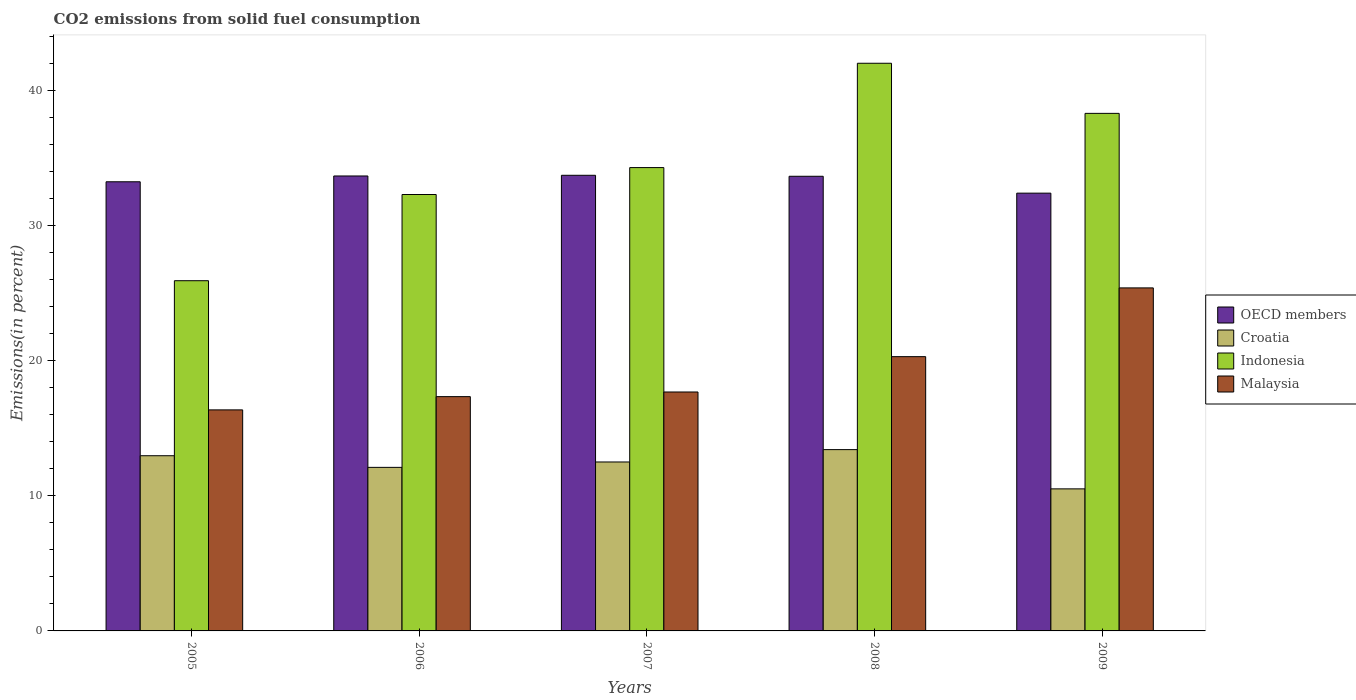How many different coloured bars are there?
Offer a very short reply. 4. Are the number of bars per tick equal to the number of legend labels?
Give a very brief answer. Yes. Are the number of bars on each tick of the X-axis equal?
Your answer should be very brief. Yes. How many bars are there on the 2nd tick from the left?
Provide a succinct answer. 4. How many bars are there on the 1st tick from the right?
Offer a terse response. 4. What is the label of the 4th group of bars from the left?
Provide a succinct answer. 2008. What is the total CO2 emitted in Croatia in 2005?
Make the answer very short. 12.97. Across all years, what is the maximum total CO2 emitted in Malaysia?
Make the answer very short. 25.39. Across all years, what is the minimum total CO2 emitted in OECD members?
Offer a very short reply. 32.4. In which year was the total CO2 emitted in Croatia maximum?
Give a very brief answer. 2008. In which year was the total CO2 emitted in Croatia minimum?
Your answer should be very brief. 2009. What is the total total CO2 emitted in Indonesia in the graph?
Provide a short and direct response. 172.83. What is the difference between the total CO2 emitted in Croatia in 2007 and that in 2008?
Your answer should be very brief. -0.91. What is the difference between the total CO2 emitted in Croatia in 2008 and the total CO2 emitted in Malaysia in 2006?
Your answer should be compact. -3.92. What is the average total CO2 emitted in OECD members per year?
Keep it short and to the point. 33.34. In the year 2005, what is the difference between the total CO2 emitted in Malaysia and total CO2 emitted in Croatia?
Offer a terse response. 3.39. What is the ratio of the total CO2 emitted in Croatia in 2005 to that in 2006?
Provide a short and direct response. 1.07. What is the difference between the highest and the second highest total CO2 emitted in Croatia?
Give a very brief answer. 0.45. What is the difference between the highest and the lowest total CO2 emitted in Indonesia?
Offer a terse response. 16.09. What does the 3rd bar from the left in 2005 represents?
Make the answer very short. Indonesia. What does the 3rd bar from the right in 2008 represents?
Your answer should be very brief. Croatia. Is it the case that in every year, the sum of the total CO2 emitted in Malaysia and total CO2 emitted in Indonesia is greater than the total CO2 emitted in Croatia?
Ensure brevity in your answer.  Yes. How many bars are there?
Offer a terse response. 20. What is the difference between two consecutive major ticks on the Y-axis?
Keep it short and to the point. 10. Does the graph contain any zero values?
Your answer should be very brief. No. Does the graph contain grids?
Ensure brevity in your answer.  No. Where does the legend appear in the graph?
Make the answer very short. Center right. How are the legend labels stacked?
Keep it short and to the point. Vertical. What is the title of the graph?
Your answer should be compact. CO2 emissions from solid fuel consumption. What is the label or title of the Y-axis?
Provide a short and direct response. Emissions(in percent). What is the Emissions(in percent) in OECD members in 2005?
Provide a succinct answer. 33.24. What is the Emissions(in percent) in Croatia in 2005?
Provide a succinct answer. 12.97. What is the Emissions(in percent) of Indonesia in 2005?
Ensure brevity in your answer.  25.92. What is the Emissions(in percent) in Malaysia in 2005?
Provide a succinct answer. 16.36. What is the Emissions(in percent) of OECD members in 2006?
Make the answer very short. 33.67. What is the Emissions(in percent) in Croatia in 2006?
Offer a very short reply. 12.1. What is the Emissions(in percent) in Indonesia in 2006?
Make the answer very short. 32.3. What is the Emissions(in percent) in Malaysia in 2006?
Ensure brevity in your answer.  17.34. What is the Emissions(in percent) in OECD members in 2007?
Provide a succinct answer. 33.72. What is the Emissions(in percent) in Croatia in 2007?
Offer a very short reply. 12.5. What is the Emissions(in percent) in Indonesia in 2007?
Provide a short and direct response. 34.29. What is the Emissions(in percent) of Malaysia in 2007?
Give a very brief answer. 17.68. What is the Emissions(in percent) in OECD members in 2008?
Keep it short and to the point. 33.65. What is the Emissions(in percent) in Croatia in 2008?
Offer a terse response. 13.42. What is the Emissions(in percent) in Indonesia in 2008?
Ensure brevity in your answer.  42.01. What is the Emissions(in percent) in Malaysia in 2008?
Give a very brief answer. 20.3. What is the Emissions(in percent) of OECD members in 2009?
Offer a very short reply. 32.4. What is the Emissions(in percent) in Croatia in 2009?
Offer a very short reply. 10.51. What is the Emissions(in percent) of Indonesia in 2009?
Offer a very short reply. 38.3. What is the Emissions(in percent) of Malaysia in 2009?
Offer a very short reply. 25.39. Across all years, what is the maximum Emissions(in percent) of OECD members?
Provide a short and direct response. 33.72. Across all years, what is the maximum Emissions(in percent) of Croatia?
Your answer should be compact. 13.42. Across all years, what is the maximum Emissions(in percent) of Indonesia?
Offer a terse response. 42.01. Across all years, what is the maximum Emissions(in percent) of Malaysia?
Ensure brevity in your answer.  25.39. Across all years, what is the minimum Emissions(in percent) of OECD members?
Your answer should be very brief. 32.4. Across all years, what is the minimum Emissions(in percent) of Croatia?
Provide a succinct answer. 10.51. Across all years, what is the minimum Emissions(in percent) in Indonesia?
Provide a succinct answer. 25.92. Across all years, what is the minimum Emissions(in percent) in Malaysia?
Make the answer very short. 16.36. What is the total Emissions(in percent) of OECD members in the graph?
Provide a succinct answer. 166.68. What is the total Emissions(in percent) of Croatia in the graph?
Make the answer very short. 61.51. What is the total Emissions(in percent) in Indonesia in the graph?
Your answer should be very brief. 172.83. What is the total Emissions(in percent) of Malaysia in the graph?
Make the answer very short. 97.07. What is the difference between the Emissions(in percent) in OECD members in 2005 and that in 2006?
Your answer should be compact. -0.43. What is the difference between the Emissions(in percent) of Croatia in 2005 and that in 2006?
Ensure brevity in your answer.  0.86. What is the difference between the Emissions(in percent) in Indonesia in 2005 and that in 2006?
Ensure brevity in your answer.  -6.38. What is the difference between the Emissions(in percent) in Malaysia in 2005 and that in 2006?
Your answer should be compact. -0.98. What is the difference between the Emissions(in percent) in OECD members in 2005 and that in 2007?
Keep it short and to the point. -0.48. What is the difference between the Emissions(in percent) in Croatia in 2005 and that in 2007?
Offer a very short reply. 0.46. What is the difference between the Emissions(in percent) in Indonesia in 2005 and that in 2007?
Keep it short and to the point. -8.37. What is the difference between the Emissions(in percent) of Malaysia in 2005 and that in 2007?
Provide a succinct answer. -1.32. What is the difference between the Emissions(in percent) of OECD members in 2005 and that in 2008?
Your response must be concise. -0.41. What is the difference between the Emissions(in percent) of Croatia in 2005 and that in 2008?
Ensure brevity in your answer.  -0.45. What is the difference between the Emissions(in percent) in Indonesia in 2005 and that in 2008?
Your answer should be compact. -16.09. What is the difference between the Emissions(in percent) of Malaysia in 2005 and that in 2008?
Keep it short and to the point. -3.94. What is the difference between the Emissions(in percent) of OECD members in 2005 and that in 2009?
Keep it short and to the point. 0.84. What is the difference between the Emissions(in percent) in Croatia in 2005 and that in 2009?
Offer a very short reply. 2.45. What is the difference between the Emissions(in percent) of Indonesia in 2005 and that in 2009?
Provide a succinct answer. -12.38. What is the difference between the Emissions(in percent) in Malaysia in 2005 and that in 2009?
Ensure brevity in your answer.  -9.03. What is the difference between the Emissions(in percent) of OECD members in 2006 and that in 2007?
Your answer should be very brief. -0.05. What is the difference between the Emissions(in percent) of Croatia in 2006 and that in 2007?
Ensure brevity in your answer.  -0.4. What is the difference between the Emissions(in percent) in Indonesia in 2006 and that in 2007?
Your response must be concise. -1.99. What is the difference between the Emissions(in percent) of Malaysia in 2006 and that in 2007?
Make the answer very short. -0.34. What is the difference between the Emissions(in percent) of OECD members in 2006 and that in 2008?
Your response must be concise. 0.02. What is the difference between the Emissions(in percent) of Croatia in 2006 and that in 2008?
Ensure brevity in your answer.  -1.31. What is the difference between the Emissions(in percent) of Indonesia in 2006 and that in 2008?
Provide a succinct answer. -9.71. What is the difference between the Emissions(in percent) of Malaysia in 2006 and that in 2008?
Your answer should be very brief. -2.96. What is the difference between the Emissions(in percent) of OECD members in 2006 and that in 2009?
Your answer should be very brief. 1.27. What is the difference between the Emissions(in percent) in Croatia in 2006 and that in 2009?
Give a very brief answer. 1.59. What is the difference between the Emissions(in percent) of Indonesia in 2006 and that in 2009?
Give a very brief answer. -6.01. What is the difference between the Emissions(in percent) of Malaysia in 2006 and that in 2009?
Give a very brief answer. -8.05. What is the difference between the Emissions(in percent) in OECD members in 2007 and that in 2008?
Provide a succinct answer. 0.07. What is the difference between the Emissions(in percent) of Croatia in 2007 and that in 2008?
Make the answer very short. -0.91. What is the difference between the Emissions(in percent) in Indonesia in 2007 and that in 2008?
Offer a very short reply. -7.72. What is the difference between the Emissions(in percent) in Malaysia in 2007 and that in 2008?
Keep it short and to the point. -2.62. What is the difference between the Emissions(in percent) in OECD members in 2007 and that in 2009?
Provide a succinct answer. 1.32. What is the difference between the Emissions(in percent) in Croatia in 2007 and that in 2009?
Offer a terse response. 1.99. What is the difference between the Emissions(in percent) in Indonesia in 2007 and that in 2009?
Ensure brevity in your answer.  -4.01. What is the difference between the Emissions(in percent) in Malaysia in 2007 and that in 2009?
Your answer should be very brief. -7.7. What is the difference between the Emissions(in percent) of OECD members in 2008 and that in 2009?
Your response must be concise. 1.25. What is the difference between the Emissions(in percent) of Croatia in 2008 and that in 2009?
Provide a succinct answer. 2.9. What is the difference between the Emissions(in percent) in Indonesia in 2008 and that in 2009?
Make the answer very short. 3.71. What is the difference between the Emissions(in percent) of Malaysia in 2008 and that in 2009?
Offer a very short reply. -5.09. What is the difference between the Emissions(in percent) in OECD members in 2005 and the Emissions(in percent) in Croatia in 2006?
Give a very brief answer. 21.14. What is the difference between the Emissions(in percent) in OECD members in 2005 and the Emissions(in percent) in Indonesia in 2006?
Ensure brevity in your answer.  0.94. What is the difference between the Emissions(in percent) of OECD members in 2005 and the Emissions(in percent) of Malaysia in 2006?
Offer a terse response. 15.9. What is the difference between the Emissions(in percent) in Croatia in 2005 and the Emissions(in percent) in Indonesia in 2006?
Give a very brief answer. -19.33. What is the difference between the Emissions(in percent) of Croatia in 2005 and the Emissions(in percent) of Malaysia in 2006?
Your answer should be very brief. -4.37. What is the difference between the Emissions(in percent) in Indonesia in 2005 and the Emissions(in percent) in Malaysia in 2006?
Your answer should be compact. 8.58. What is the difference between the Emissions(in percent) in OECD members in 2005 and the Emissions(in percent) in Croatia in 2007?
Keep it short and to the point. 20.74. What is the difference between the Emissions(in percent) of OECD members in 2005 and the Emissions(in percent) of Indonesia in 2007?
Your response must be concise. -1.05. What is the difference between the Emissions(in percent) in OECD members in 2005 and the Emissions(in percent) in Malaysia in 2007?
Ensure brevity in your answer.  15.56. What is the difference between the Emissions(in percent) in Croatia in 2005 and the Emissions(in percent) in Indonesia in 2007?
Keep it short and to the point. -21.33. What is the difference between the Emissions(in percent) in Croatia in 2005 and the Emissions(in percent) in Malaysia in 2007?
Offer a terse response. -4.72. What is the difference between the Emissions(in percent) of Indonesia in 2005 and the Emissions(in percent) of Malaysia in 2007?
Offer a terse response. 8.24. What is the difference between the Emissions(in percent) of OECD members in 2005 and the Emissions(in percent) of Croatia in 2008?
Provide a succinct answer. 19.82. What is the difference between the Emissions(in percent) in OECD members in 2005 and the Emissions(in percent) in Indonesia in 2008?
Your answer should be very brief. -8.77. What is the difference between the Emissions(in percent) in OECD members in 2005 and the Emissions(in percent) in Malaysia in 2008?
Offer a terse response. 12.94. What is the difference between the Emissions(in percent) of Croatia in 2005 and the Emissions(in percent) of Indonesia in 2008?
Your response must be concise. -29.05. What is the difference between the Emissions(in percent) of Croatia in 2005 and the Emissions(in percent) of Malaysia in 2008?
Your answer should be compact. -7.33. What is the difference between the Emissions(in percent) in Indonesia in 2005 and the Emissions(in percent) in Malaysia in 2008?
Offer a very short reply. 5.62. What is the difference between the Emissions(in percent) in OECD members in 2005 and the Emissions(in percent) in Croatia in 2009?
Provide a succinct answer. 22.73. What is the difference between the Emissions(in percent) in OECD members in 2005 and the Emissions(in percent) in Indonesia in 2009?
Give a very brief answer. -5.06. What is the difference between the Emissions(in percent) in OECD members in 2005 and the Emissions(in percent) in Malaysia in 2009?
Keep it short and to the point. 7.85. What is the difference between the Emissions(in percent) of Croatia in 2005 and the Emissions(in percent) of Indonesia in 2009?
Give a very brief answer. -25.34. What is the difference between the Emissions(in percent) in Croatia in 2005 and the Emissions(in percent) in Malaysia in 2009?
Make the answer very short. -12.42. What is the difference between the Emissions(in percent) in Indonesia in 2005 and the Emissions(in percent) in Malaysia in 2009?
Give a very brief answer. 0.53. What is the difference between the Emissions(in percent) in OECD members in 2006 and the Emissions(in percent) in Croatia in 2007?
Your answer should be compact. 21.17. What is the difference between the Emissions(in percent) of OECD members in 2006 and the Emissions(in percent) of Indonesia in 2007?
Make the answer very short. -0.62. What is the difference between the Emissions(in percent) in OECD members in 2006 and the Emissions(in percent) in Malaysia in 2007?
Your answer should be very brief. 15.99. What is the difference between the Emissions(in percent) in Croatia in 2006 and the Emissions(in percent) in Indonesia in 2007?
Give a very brief answer. -22.19. What is the difference between the Emissions(in percent) of Croatia in 2006 and the Emissions(in percent) of Malaysia in 2007?
Provide a short and direct response. -5.58. What is the difference between the Emissions(in percent) of Indonesia in 2006 and the Emissions(in percent) of Malaysia in 2007?
Your response must be concise. 14.62. What is the difference between the Emissions(in percent) in OECD members in 2006 and the Emissions(in percent) in Croatia in 2008?
Keep it short and to the point. 20.25. What is the difference between the Emissions(in percent) in OECD members in 2006 and the Emissions(in percent) in Indonesia in 2008?
Make the answer very short. -8.34. What is the difference between the Emissions(in percent) of OECD members in 2006 and the Emissions(in percent) of Malaysia in 2008?
Offer a terse response. 13.37. What is the difference between the Emissions(in percent) of Croatia in 2006 and the Emissions(in percent) of Indonesia in 2008?
Your answer should be very brief. -29.91. What is the difference between the Emissions(in percent) of Croatia in 2006 and the Emissions(in percent) of Malaysia in 2008?
Give a very brief answer. -8.19. What is the difference between the Emissions(in percent) in Indonesia in 2006 and the Emissions(in percent) in Malaysia in 2008?
Provide a short and direct response. 12. What is the difference between the Emissions(in percent) of OECD members in 2006 and the Emissions(in percent) of Croatia in 2009?
Your response must be concise. 23.16. What is the difference between the Emissions(in percent) in OECD members in 2006 and the Emissions(in percent) in Indonesia in 2009?
Your answer should be very brief. -4.63. What is the difference between the Emissions(in percent) of OECD members in 2006 and the Emissions(in percent) of Malaysia in 2009?
Your response must be concise. 8.28. What is the difference between the Emissions(in percent) of Croatia in 2006 and the Emissions(in percent) of Indonesia in 2009?
Offer a terse response. -26.2. What is the difference between the Emissions(in percent) in Croatia in 2006 and the Emissions(in percent) in Malaysia in 2009?
Provide a succinct answer. -13.28. What is the difference between the Emissions(in percent) of Indonesia in 2006 and the Emissions(in percent) of Malaysia in 2009?
Give a very brief answer. 6.91. What is the difference between the Emissions(in percent) of OECD members in 2007 and the Emissions(in percent) of Croatia in 2008?
Provide a short and direct response. 20.3. What is the difference between the Emissions(in percent) of OECD members in 2007 and the Emissions(in percent) of Indonesia in 2008?
Keep it short and to the point. -8.29. What is the difference between the Emissions(in percent) of OECD members in 2007 and the Emissions(in percent) of Malaysia in 2008?
Your answer should be compact. 13.42. What is the difference between the Emissions(in percent) of Croatia in 2007 and the Emissions(in percent) of Indonesia in 2008?
Your answer should be very brief. -29.51. What is the difference between the Emissions(in percent) in Croatia in 2007 and the Emissions(in percent) in Malaysia in 2008?
Offer a very short reply. -7.79. What is the difference between the Emissions(in percent) of Indonesia in 2007 and the Emissions(in percent) of Malaysia in 2008?
Make the answer very short. 13.99. What is the difference between the Emissions(in percent) in OECD members in 2007 and the Emissions(in percent) in Croatia in 2009?
Make the answer very short. 23.21. What is the difference between the Emissions(in percent) of OECD members in 2007 and the Emissions(in percent) of Indonesia in 2009?
Keep it short and to the point. -4.58. What is the difference between the Emissions(in percent) in OECD members in 2007 and the Emissions(in percent) in Malaysia in 2009?
Your answer should be very brief. 8.33. What is the difference between the Emissions(in percent) of Croatia in 2007 and the Emissions(in percent) of Indonesia in 2009?
Your answer should be very brief. -25.8. What is the difference between the Emissions(in percent) in Croatia in 2007 and the Emissions(in percent) in Malaysia in 2009?
Offer a terse response. -12.88. What is the difference between the Emissions(in percent) in Indonesia in 2007 and the Emissions(in percent) in Malaysia in 2009?
Give a very brief answer. 8.9. What is the difference between the Emissions(in percent) of OECD members in 2008 and the Emissions(in percent) of Croatia in 2009?
Your answer should be compact. 23.13. What is the difference between the Emissions(in percent) of OECD members in 2008 and the Emissions(in percent) of Indonesia in 2009?
Your answer should be very brief. -4.66. What is the difference between the Emissions(in percent) of OECD members in 2008 and the Emissions(in percent) of Malaysia in 2009?
Offer a terse response. 8.26. What is the difference between the Emissions(in percent) of Croatia in 2008 and the Emissions(in percent) of Indonesia in 2009?
Your answer should be compact. -24.89. What is the difference between the Emissions(in percent) of Croatia in 2008 and the Emissions(in percent) of Malaysia in 2009?
Offer a very short reply. -11.97. What is the difference between the Emissions(in percent) of Indonesia in 2008 and the Emissions(in percent) of Malaysia in 2009?
Give a very brief answer. 16.63. What is the average Emissions(in percent) in OECD members per year?
Give a very brief answer. 33.34. What is the average Emissions(in percent) in Croatia per year?
Provide a succinct answer. 12.3. What is the average Emissions(in percent) of Indonesia per year?
Offer a very short reply. 34.57. What is the average Emissions(in percent) in Malaysia per year?
Your response must be concise. 19.41. In the year 2005, what is the difference between the Emissions(in percent) in OECD members and Emissions(in percent) in Croatia?
Offer a terse response. 20.27. In the year 2005, what is the difference between the Emissions(in percent) in OECD members and Emissions(in percent) in Indonesia?
Offer a terse response. 7.32. In the year 2005, what is the difference between the Emissions(in percent) of OECD members and Emissions(in percent) of Malaysia?
Your response must be concise. 16.88. In the year 2005, what is the difference between the Emissions(in percent) of Croatia and Emissions(in percent) of Indonesia?
Offer a terse response. -12.95. In the year 2005, what is the difference between the Emissions(in percent) in Croatia and Emissions(in percent) in Malaysia?
Your answer should be compact. -3.39. In the year 2005, what is the difference between the Emissions(in percent) in Indonesia and Emissions(in percent) in Malaysia?
Offer a very short reply. 9.56. In the year 2006, what is the difference between the Emissions(in percent) in OECD members and Emissions(in percent) in Croatia?
Provide a short and direct response. 21.57. In the year 2006, what is the difference between the Emissions(in percent) of OECD members and Emissions(in percent) of Indonesia?
Make the answer very short. 1.37. In the year 2006, what is the difference between the Emissions(in percent) in OECD members and Emissions(in percent) in Malaysia?
Ensure brevity in your answer.  16.33. In the year 2006, what is the difference between the Emissions(in percent) in Croatia and Emissions(in percent) in Indonesia?
Your answer should be compact. -20.19. In the year 2006, what is the difference between the Emissions(in percent) of Croatia and Emissions(in percent) of Malaysia?
Keep it short and to the point. -5.23. In the year 2006, what is the difference between the Emissions(in percent) of Indonesia and Emissions(in percent) of Malaysia?
Your answer should be compact. 14.96. In the year 2007, what is the difference between the Emissions(in percent) of OECD members and Emissions(in percent) of Croatia?
Provide a short and direct response. 21.22. In the year 2007, what is the difference between the Emissions(in percent) in OECD members and Emissions(in percent) in Indonesia?
Make the answer very short. -0.57. In the year 2007, what is the difference between the Emissions(in percent) in OECD members and Emissions(in percent) in Malaysia?
Ensure brevity in your answer.  16.04. In the year 2007, what is the difference between the Emissions(in percent) in Croatia and Emissions(in percent) in Indonesia?
Your answer should be very brief. -21.79. In the year 2007, what is the difference between the Emissions(in percent) of Croatia and Emissions(in percent) of Malaysia?
Ensure brevity in your answer.  -5.18. In the year 2007, what is the difference between the Emissions(in percent) of Indonesia and Emissions(in percent) of Malaysia?
Provide a short and direct response. 16.61. In the year 2008, what is the difference between the Emissions(in percent) of OECD members and Emissions(in percent) of Croatia?
Provide a succinct answer. 20.23. In the year 2008, what is the difference between the Emissions(in percent) in OECD members and Emissions(in percent) in Indonesia?
Offer a terse response. -8.36. In the year 2008, what is the difference between the Emissions(in percent) of OECD members and Emissions(in percent) of Malaysia?
Make the answer very short. 13.35. In the year 2008, what is the difference between the Emissions(in percent) of Croatia and Emissions(in percent) of Indonesia?
Provide a short and direct response. -28.59. In the year 2008, what is the difference between the Emissions(in percent) in Croatia and Emissions(in percent) in Malaysia?
Ensure brevity in your answer.  -6.88. In the year 2008, what is the difference between the Emissions(in percent) of Indonesia and Emissions(in percent) of Malaysia?
Your response must be concise. 21.71. In the year 2009, what is the difference between the Emissions(in percent) in OECD members and Emissions(in percent) in Croatia?
Your response must be concise. 21.89. In the year 2009, what is the difference between the Emissions(in percent) in OECD members and Emissions(in percent) in Indonesia?
Make the answer very short. -5.9. In the year 2009, what is the difference between the Emissions(in percent) in OECD members and Emissions(in percent) in Malaysia?
Provide a short and direct response. 7.01. In the year 2009, what is the difference between the Emissions(in percent) of Croatia and Emissions(in percent) of Indonesia?
Offer a terse response. -27.79. In the year 2009, what is the difference between the Emissions(in percent) in Croatia and Emissions(in percent) in Malaysia?
Provide a short and direct response. -14.87. In the year 2009, what is the difference between the Emissions(in percent) in Indonesia and Emissions(in percent) in Malaysia?
Your answer should be very brief. 12.92. What is the ratio of the Emissions(in percent) of OECD members in 2005 to that in 2006?
Your answer should be very brief. 0.99. What is the ratio of the Emissions(in percent) of Croatia in 2005 to that in 2006?
Your answer should be compact. 1.07. What is the ratio of the Emissions(in percent) of Indonesia in 2005 to that in 2006?
Offer a terse response. 0.8. What is the ratio of the Emissions(in percent) in Malaysia in 2005 to that in 2006?
Keep it short and to the point. 0.94. What is the ratio of the Emissions(in percent) of OECD members in 2005 to that in 2007?
Offer a terse response. 0.99. What is the ratio of the Emissions(in percent) in Indonesia in 2005 to that in 2007?
Offer a very short reply. 0.76. What is the ratio of the Emissions(in percent) of Malaysia in 2005 to that in 2007?
Your answer should be compact. 0.93. What is the ratio of the Emissions(in percent) in OECD members in 2005 to that in 2008?
Your response must be concise. 0.99. What is the ratio of the Emissions(in percent) of Croatia in 2005 to that in 2008?
Offer a terse response. 0.97. What is the ratio of the Emissions(in percent) in Indonesia in 2005 to that in 2008?
Offer a very short reply. 0.62. What is the ratio of the Emissions(in percent) in Malaysia in 2005 to that in 2008?
Your answer should be very brief. 0.81. What is the ratio of the Emissions(in percent) in Croatia in 2005 to that in 2009?
Offer a very short reply. 1.23. What is the ratio of the Emissions(in percent) in Indonesia in 2005 to that in 2009?
Provide a short and direct response. 0.68. What is the ratio of the Emissions(in percent) in Malaysia in 2005 to that in 2009?
Provide a short and direct response. 0.64. What is the ratio of the Emissions(in percent) of OECD members in 2006 to that in 2007?
Your answer should be very brief. 1. What is the ratio of the Emissions(in percent) in Croatia in 2006 to that in 2007?
Ensure brevity in your answer.  0.97. What is the ratio of the Emissions(in percent) in Indonesia in 2006 to that in 2007?
Offer a terse response. 0.94. What is the ratio of the Emissions(in percent) in Malaysia in 2006 to that in 2007?
Offer a very short reply. 0.98. What is the ratio of the Emissions(in percent) in Croatia in 2006 to that in 2008?
Your answer should be compact. 0.9. What is the ratio of the Emissions(in percent) in Indonesia in 2006 to that in 2008?
Offer a very short reply. 0.77. What is the ratio of the Emissions(in percent) in Malaysia in 2006 to that in 2008?
Offer a very short reply. 0.85. What is the ratio of the Emissions(in percent) of OECD members in 2006 to that in 2009?
Keep it short and to the point. 1.04. What is the ratio of the Emissions(in percent) in Croatia in 2006 to that in 2009?
Provide a succinct answer. 1.15. What is the ratio of the Emissions(in percent) of Indonesia in 2006 to that in 2009?
Your answer should be very brief. 0.84. What is the ratio of the Emissions(in percent) of Malaysia in 2006 to that in 2009?
Keep it short and to the point. 0.68. What is the ratio of the Emissions(in percent) in OECD members in 2007 to that in 2008?
Give a very brief answer. 1. What is the ratio of the Emissions(in percent) of Croatia in 2007 to that in 2008?
Your answer should be compact. 0.93. What is the ratio of the Emissions(in percent) in Indonesia in 2007 to that in 2008?
Provide a short and direct response. 0.82. What is the ratio of the Emissions(in percent) of Malaysia in 2007 to that in 2008?
Make the answer very short. 0.87. What is the ratio of the Emissions(in percent) of OECD members in 2007 to that in 2009?
Give a very brief answer. 1.04. What is the ratio of the Emissions(in percent) of Croatia in 2007 to that in 2009?
Ensure brevity in your answer.  1.19. What is the ratio of the Emissions(in percent) in Indonesia in 2007 to that in 2009?
Offer a very short reply. 0.9. What is the ratio of the Emissions(in percent) in Malaysia in 2007 to that in 2009?
Your response must be concise. 0.7. What is the ratio of the Emissions(in percent) in OECD members in 2008 to that in 2009?
Offer a terse response. 1.04. What is the ratio of the Emissions(in percent) of Croatia in 2008 to that in 2009?
Provide a succinct answer. 1.28. What is the ratio of the Emissions(in percent) in Indonesia in 2008 to that in 2009?
Offer a terse response. 1.1. What is the ratio of the Emissions(in percent) of Malaysia in 2008 to that in 2009?
Provide a short and direct response. 0.8. What is the difference between the highest and the second highest Emissions(in percent) in OECD members?
Provide a short and direct response. 0.05. What is the difference between the highest and the second highest Emissions(in percent) in Croatia?
Provide a succinct answer. 0.45. What is the difference between the highest and the second highest Emissions(in percent) of Indonesia?
Provide a short and direct response. 3.71. What is the difference between the highest and the second highest Emissions(in percent) of Malaysia?
Provide a succinct answer. 5.09. What is the difference between the highest and the lowest Emissions(in percent) of OECD members?
Ensure brevity in your answer.  1.32. What is the difference between the highest and the lowest Emissions(in percent) of Croatia?
Make the answer very short. 2.9. What is the difference between the highest and the lowest Emissions(in percent) in Indonesia?
Give a very brief answer. 16.09. What is the difference between the highest and the lowest Emissions(in percent) in Malaysia?
Ensure brevity in your answer.  9.03. 